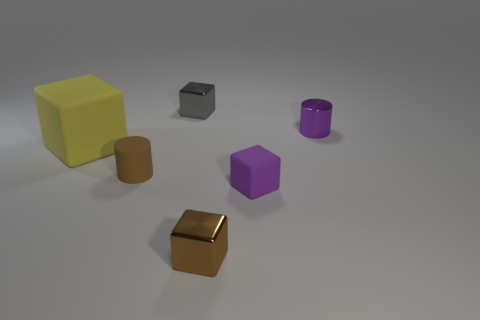Add 4 small red things. How many objects exist? 10 Subtract all cylinders. How many objects are left? 4 Subtract all tiny gray balls. Subtract all metal cylinders. How many objects are left? 5 Add 5 yellow objects. How many yellow objects are left? 6 Add 4 tiny metallic cylinders. How many tiny metallic cylinders exist? 5 Subtract 0 cyan balls. How many objects are left? 6 